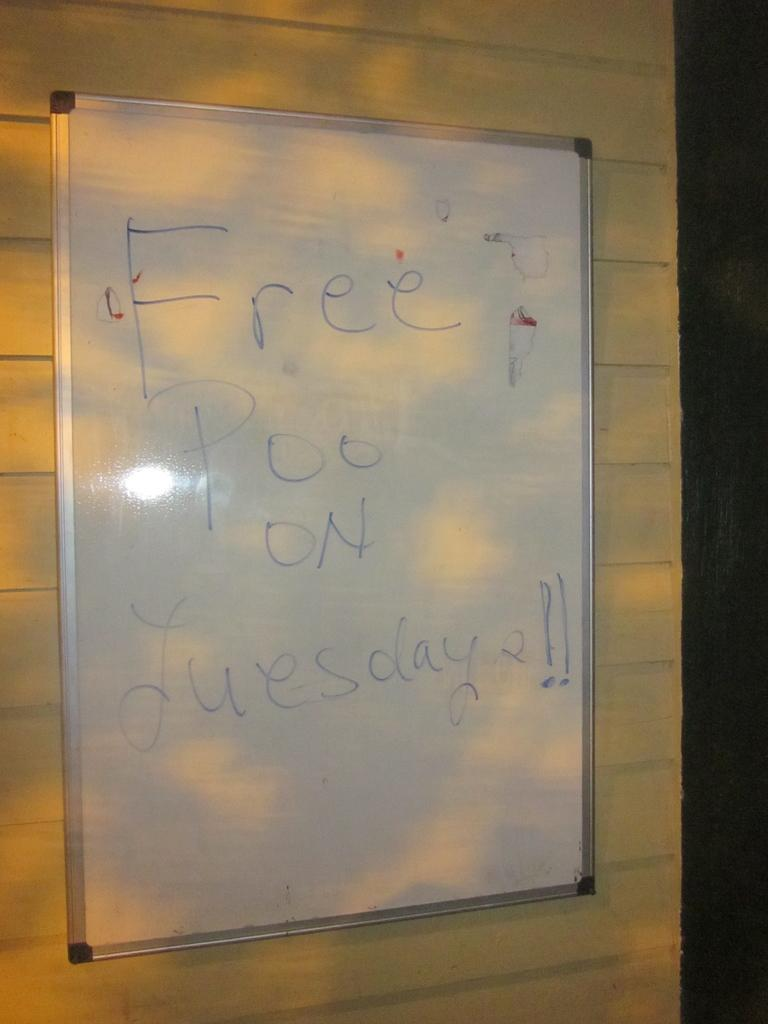<image>
Render a clear and concise summary of the photo. A whiteboard hanging up advertises free poo on Tuesday. 